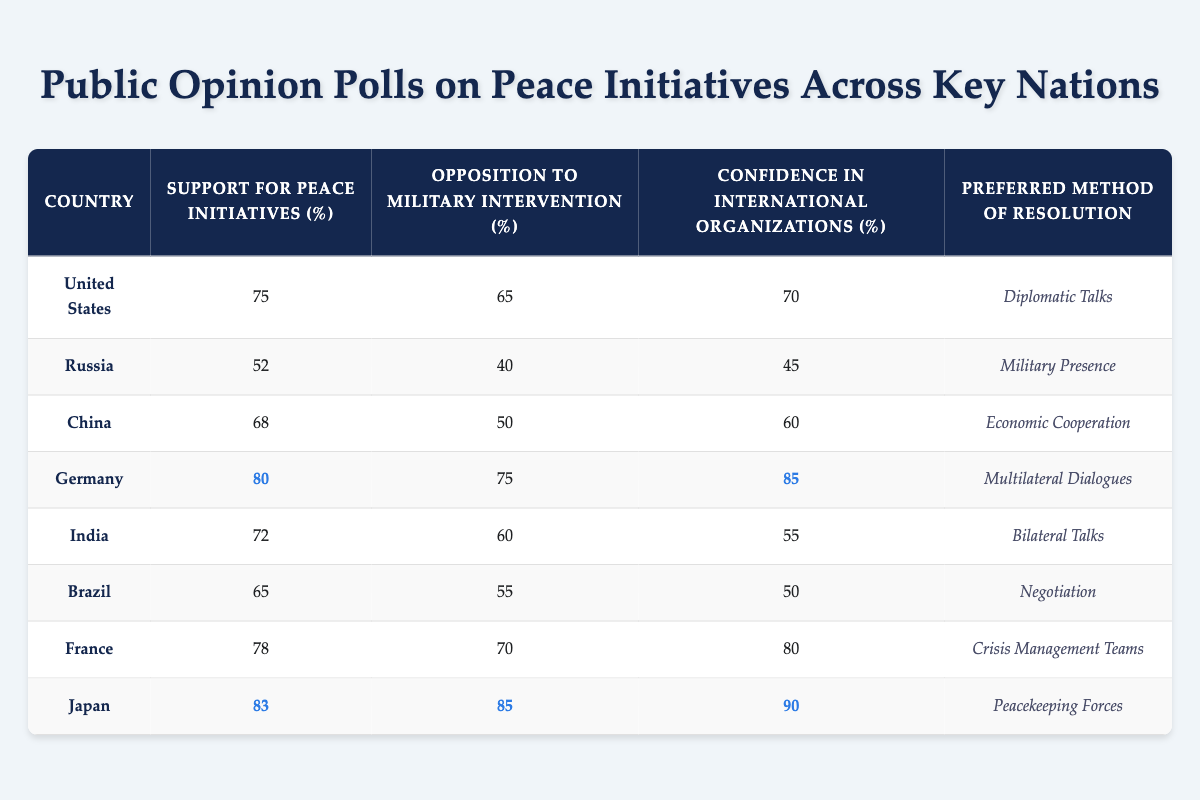What is the highest level of support for peace initiatives among the countries listed? The table indicates the support for peace initiatives for each country. Germany has a support level of 80%, which is the highest among all countries mentioned in the table.
Answer: 80% Which country has the lowest opposition to military intervention? The table shows the percentage of opposition to military intervention for each country. Russia has the lowest opposition level at 40%.
Answer: 40% What is the average confidence in international organizations across these countries? To find the average, we sum the confidence levels: (70 + 45 + 60 + 85 + 55 + 50 + 80 + 90) = 630. We then divide by the number of countries, which is 8: 630/8 = 78.75.
Answer: 78.75 Is Japan's opposition to military intervention higher than China’s? Japan has an opposition level of 85%, while China has 50%. Since 85% is greater than 50%, the statement is true.
Answer: Yes Which preferred method of resolution has the majority of countries selected? Reviewing the table, four countries prefer "Diplomatic Talks" (USA, Germany, and India), one country prefers "Multilateral Dialogues" (Germany), one country prefers "Bilateral Talks" (India), two countries prefer "Crisis Management Teams" (France), and Japan has "Peacekeeping Forces". Since “Diplomatic Talks” is listed for three countries, it is the most selected preference.
Answer: Diplomatic Talks What is the difference in support for peace initiatives between the United States and Russia? The support for the United States is 75% and for Russia is 52%. The difference is calculated as 75 - 52 = 23.
Answer: 23 Which country shows the most confidence in international organizations? The confidence levels are listed for each country. Japan shows the highest confidence with a level of 90%.
Answer: 90% How many countries have a support for peace initiatives above 70%? The countries with support levels above 70% are the United States (75), Germany (80), Japan (83), and France (78). This totals four countries.
Answer: 4 What percentage of countries prefer military presence as their resolution method? Reviewing the table, only Russia prefers "Military Presence". Since there are 8 countries total, the percentage is calculated as (1/8) * 100 = 12.5%.
Answer: 12.5% If we consider "Crisis Management Teams" as an acceptable method of resolution, how many countries support methods other than diplomatic or multilateral dialogues? The countries offering other methods are Russia (Military Presence), China (Economic Cooperation), Brazil (Negotiation), and Japan (Peacekeeping Forces). This totals four countries.
Answer: 4 